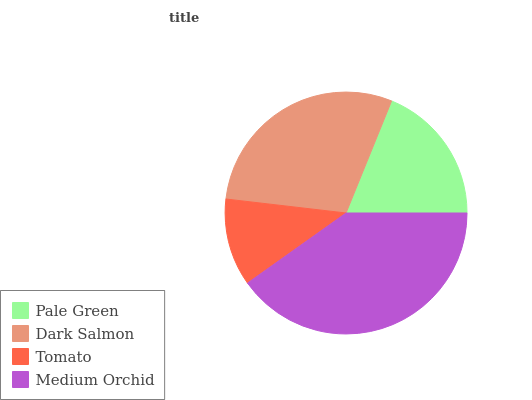Is Tomato the minimum?
Answer yes or no. Yes. Is Medium Orchid the maximum?
Answer yes or no. Yes. Is Dark Salmon the minimum?
Answer yes or no. No. Is Dark Salmon the maximum?
Answer yes or no. No. Is Dark Salmon greater than Pale Green?
Answer yes or no. Yes. Is Pale Green less than Dark Salmon?
Answer yes or no. Yes. Is Pale Green greater than Dark Salmon?
Answer yes or no. No. Is Dark Salmon less than Pale Green?
Answer yes or no. No. Is Dark Salmon the high median?
Answer yes or no. Yes. Is Pale Green the low median?
Answer yes or no. Yes. Is Tomato the high median?
Answer yes or no. No. Is Dark Salmon the low median?
Answer yes or no. No. 